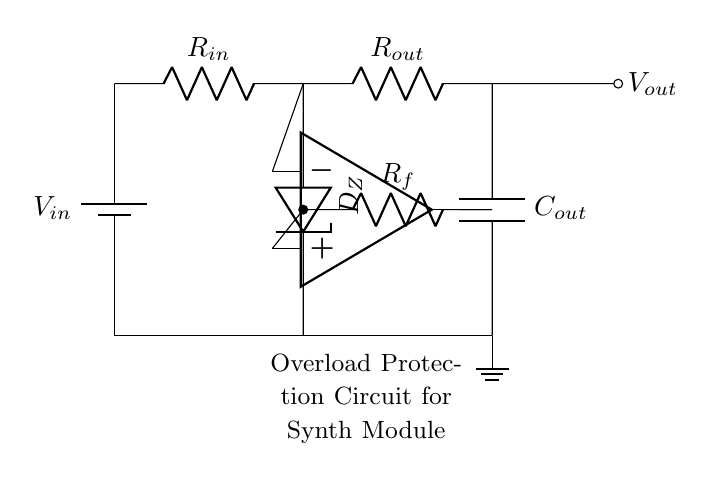What is the type of protection implemented in this circuit? The circuit features overload protection, which is indicated by the inclusion of a Zener diode in its design. The Zener diode helps to clamp voltage levels to prevent damage from excessive current.
Answer: overload protection What component is used for voltage regulation in this circuit? The Zener diode serves as the voltage regulation component. It regulates voltage by allowing current to pass in the reverse direction when a certain voltage threshold is reached.
Answer: Zener diode What is the purpose of the resistor labeled Rf? The feedback resistor Rf stabilizes the operational amplifier by creating a feedback loop that helps control the gain and response of the circuit.
Answer: stability Which component is responsible for filtering in this circuit? The output capacitor, labeled Cout, filters the output voltage by smoothing out fluctuations and providing stability to the output signal.
Answer: output capacitor How many resistors are present in this circuit? There are two resistors present: Rin (input resistor) and Rf (feedback resistor). Both are essential for different functions within the circuit.
Answer: two What does the output voltage represent in this circuit? The output voltage, labeled Vout, represents the processed voltage that has undergone regulation and protection through the components within the circuit.
Answer: processed voltage 